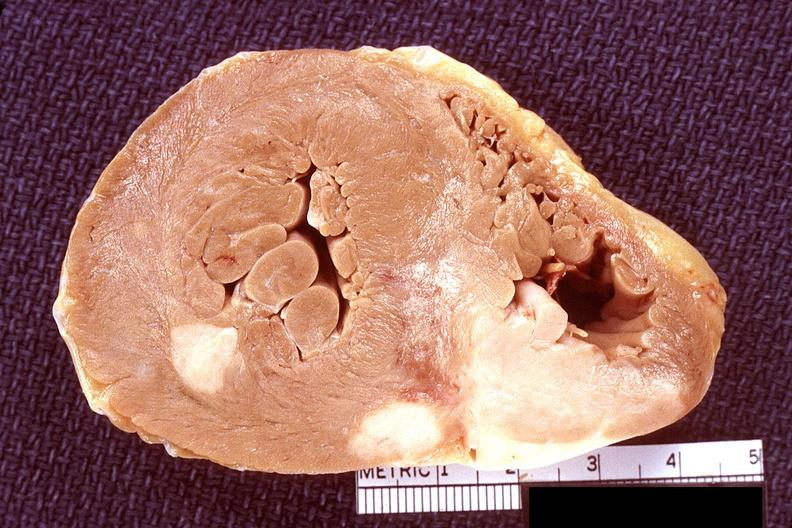what is present?
Answer the question using a single word or phrase. Cardiovascular 